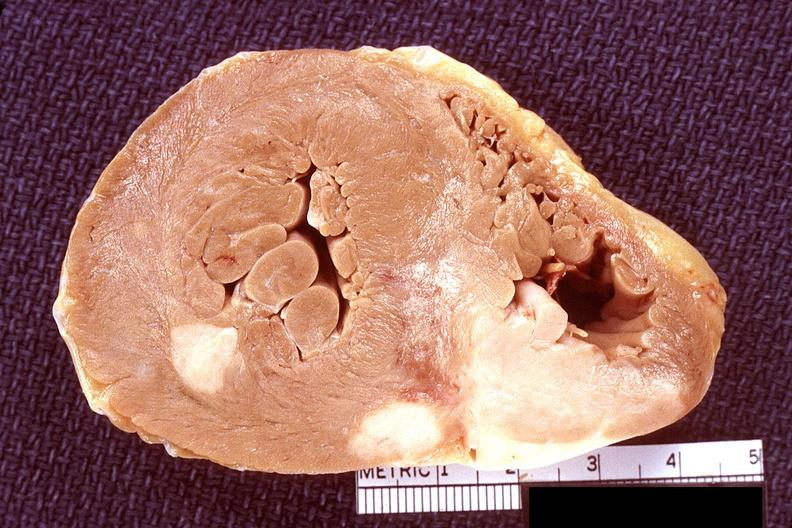what is present?
Answer the question using a single word or phrase. Cardiovascular 